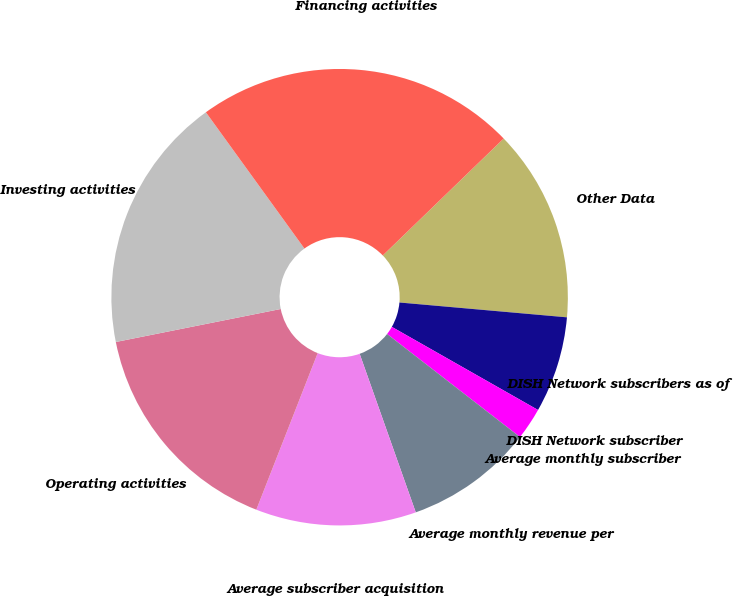<chart> <loc_0><loc_0><loc_500><loc_500><pie_chart><fcel>Other Data<fcel>DISH Network subscribers as of<fcel>DISH Network subscriber<fcel>Average monthly subscriber<fcel>Average monthly revenue per<fcel>Average subscriber acquisition<fcel>Operating activities<fcel>Investing activities<fcel>Financing activities<nl><fcel>13.64%<fcel>6.82%<fcel>0.0%<fcel>2.27%<fcel>9.09%<fcel>11.36%<fcel>15.91%<fcel>18.18%<fcel>22.73%<nl></chart> 